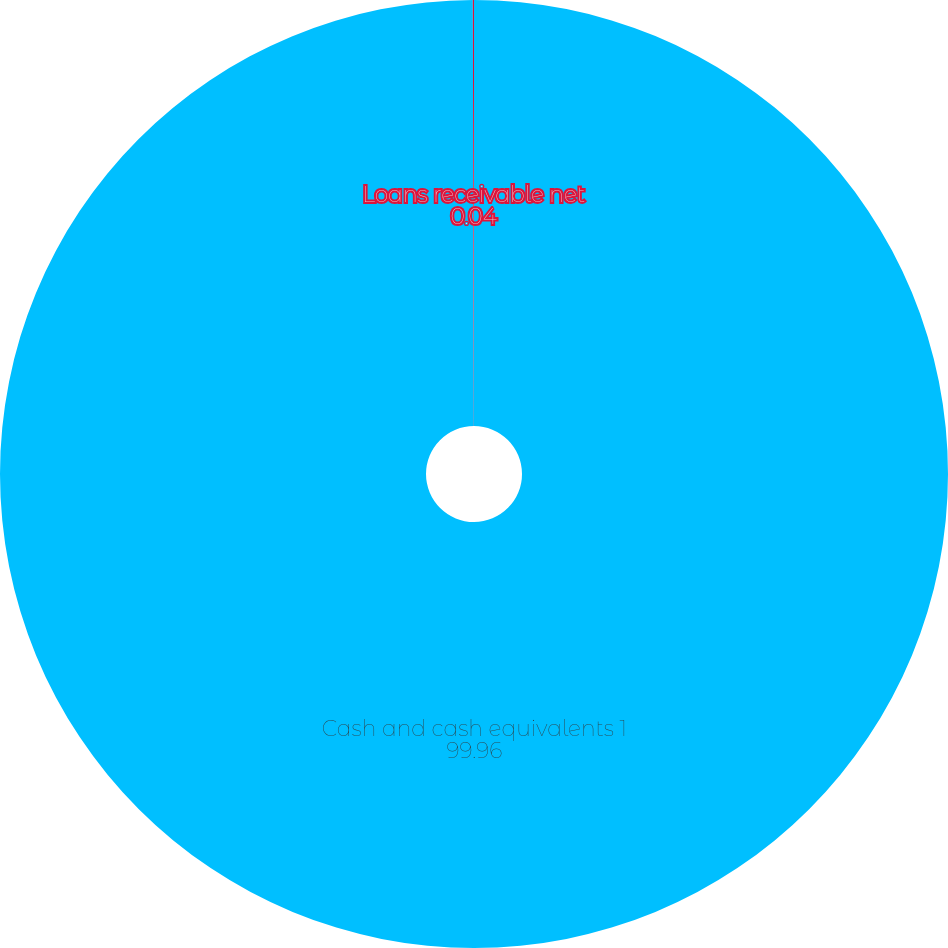Convert chart. <chart><loc_0><loc_0><loc_500><loc_500><pie_chart><fcel>Cash and cash equivalents 1<fcel>Loans receivable net<nl><fcel>99.96%<fcel>0.04%<nl></chart> 